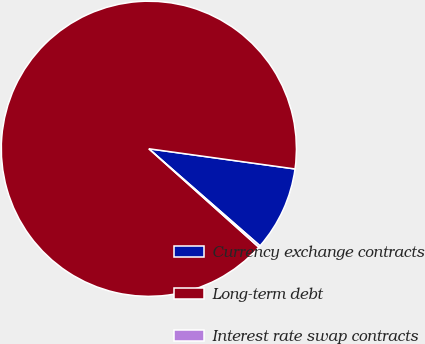Convert chart to OTSL. <chart><loc_0><loc_0><loc_500><loc_500><pie_chart><fcel>Currency exchange contracts<fcel>Long-term debt<fcel>Interest rate swap contracts<nl><fcel>9.24%<fcel>90.56%<fcel>0.2%<nl></chart> 